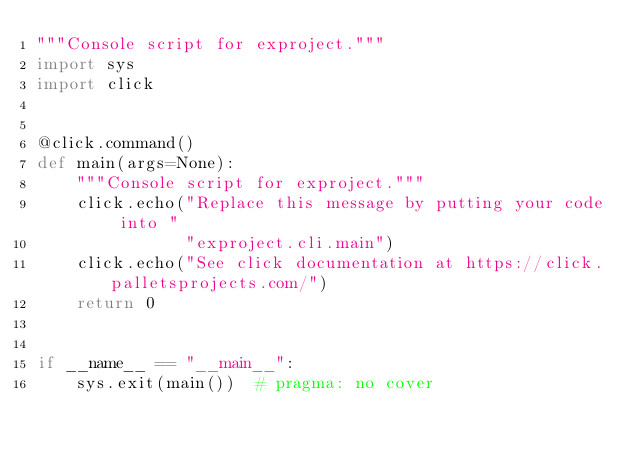<code> <loc_0><loc_0><loc_500><loc_500><_Python_>"""Console script for exproject."""
import sys
import click


@click.command()
def main(args=None):
    """Console script for exproject."""
    click.echo("Replace this message by putting your code into "
               "exproject.cli.main")
    click.echo("See click documentation at https://click.palletsprojects.com/")
    return 0


if __name__ == "__main__":
    sys.exit(main())  # pragma: no cover
</code> 